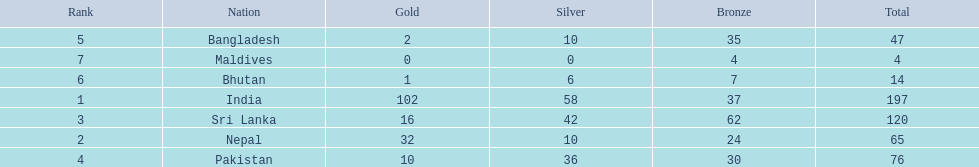Which countries won medals? India, Nepal, Sri Lanka, Pakistan, Bangladesh, Bhutan, Maldives. Which won the most? India. Which won the fewest? Maldives. 